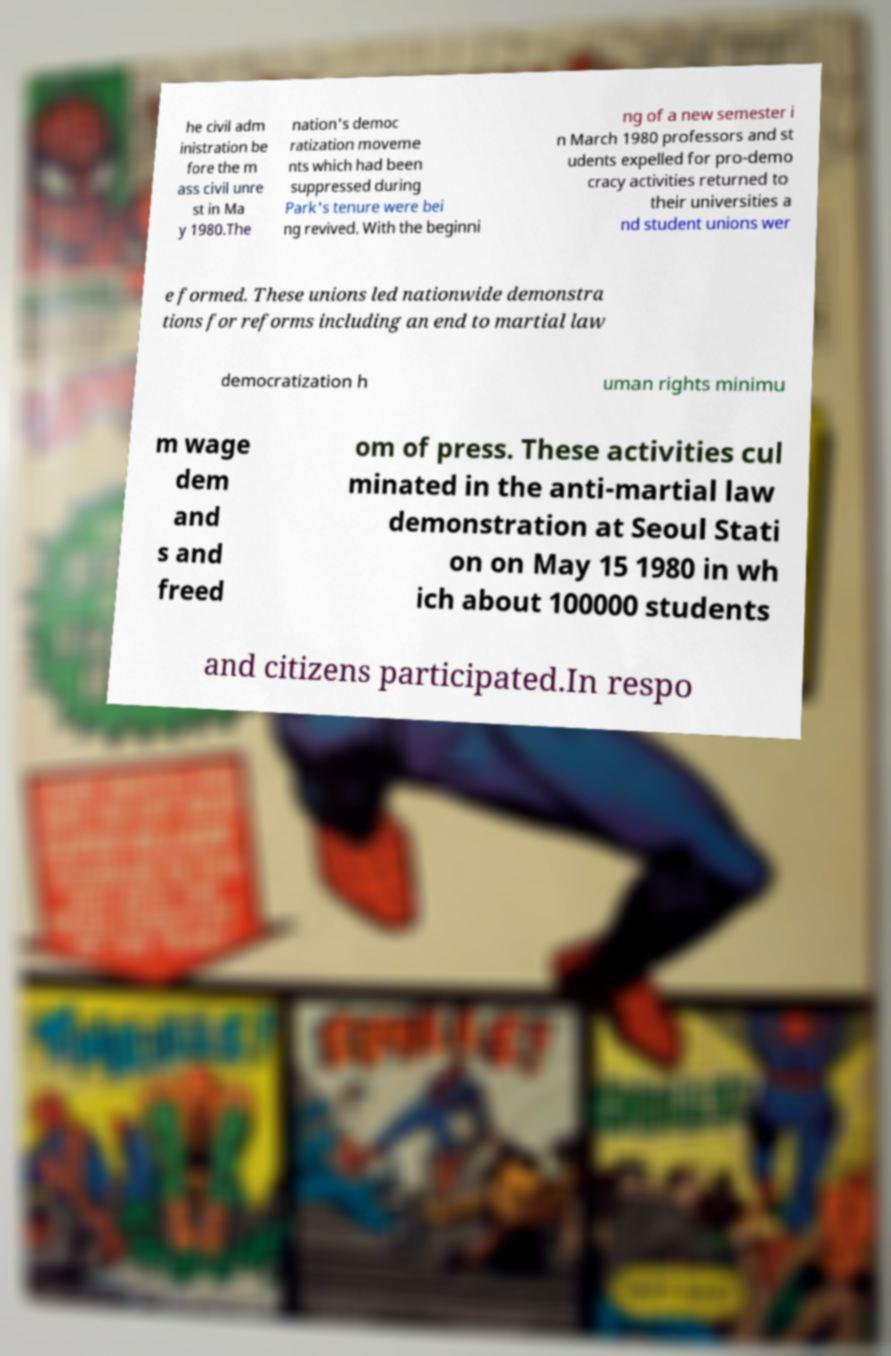I need the written content from this picture converted into text. Can you do that? he civil adm inistration be fore the m ass civil unre st in Ma y 1980.The nation's democ ratization moveme nts which had been suppressed during Park's tenure were bei ng revived. With the beginni ng of a new semester i n March 1980 professors and st udents expelled for pro-demo cracy activities returned to their universities a nd student unions wer e formed. These unions led nationwide demonstra tions for reforms including an end to martial law democratization h uman rights minimu m wage dem and s and freed om of press. These activities cul minated in the anti-martial law demonstration at Seoul Stati on on May 15 1980 in wh ich about 100000 students and citizens participated.In respo 